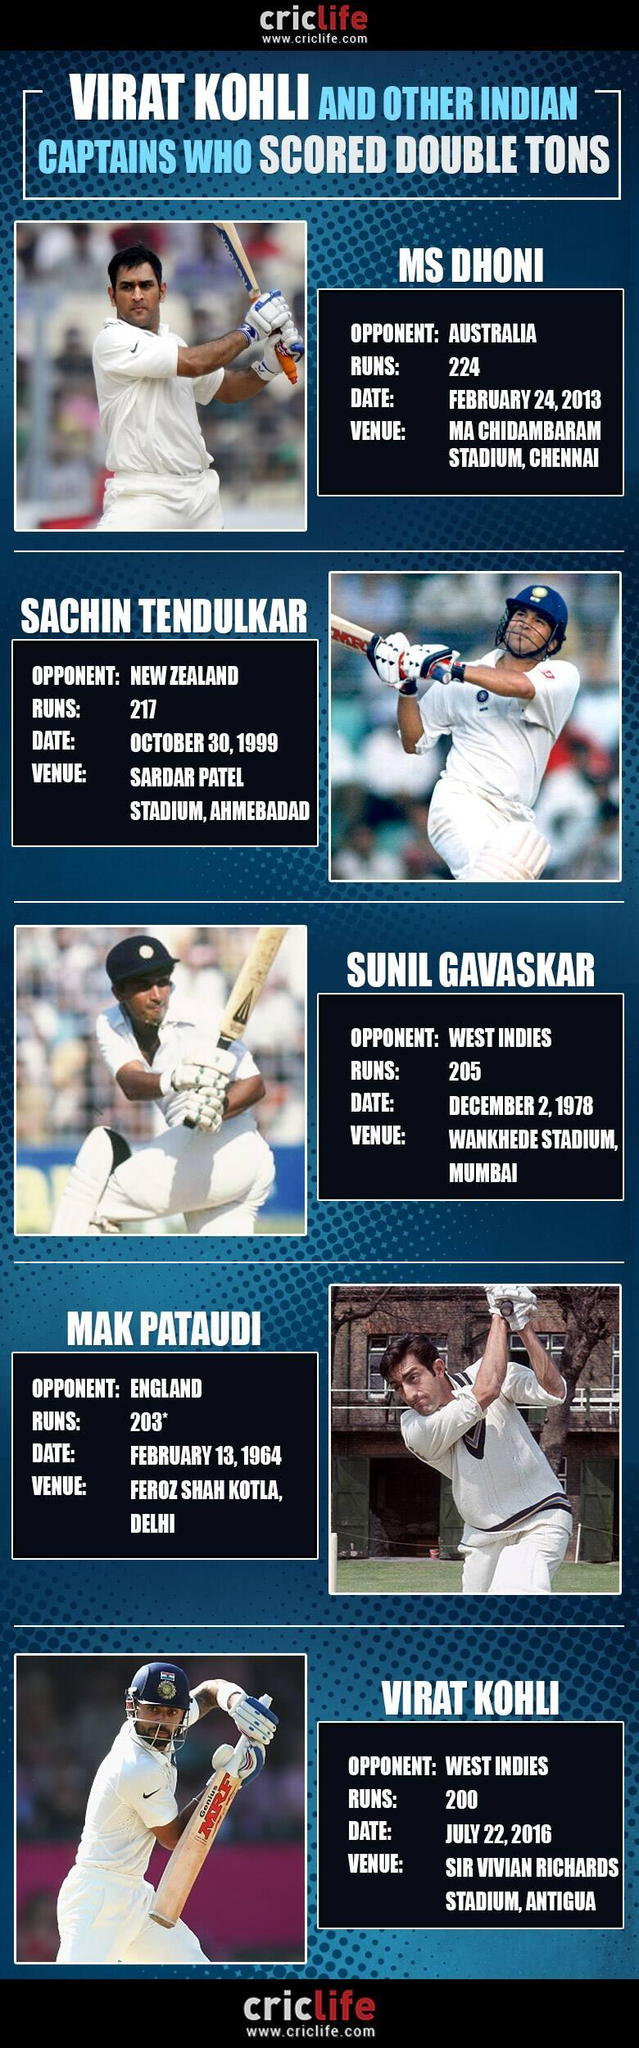Mention a couple of crucial points in this snapshot. This infographic includes five images of cricketers. 